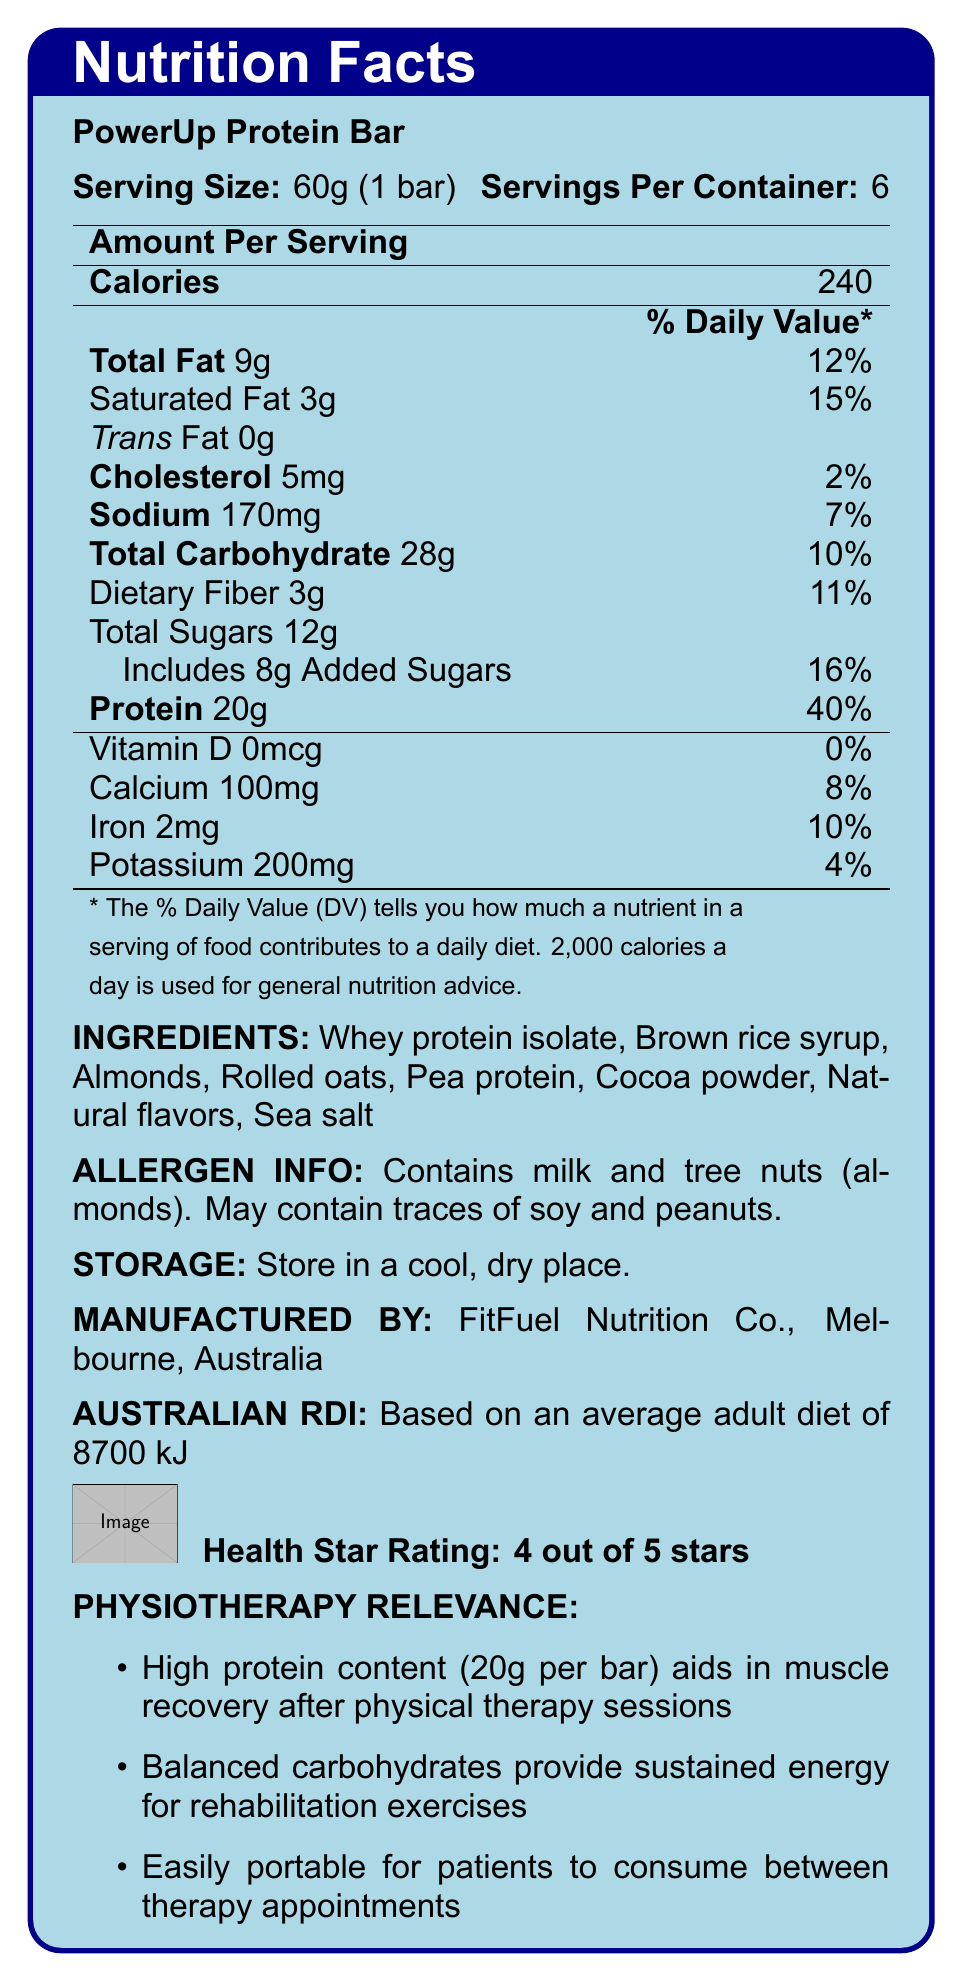what is the serving size of the PowerUp Protein Bar? The document states that the serving size is 60g, which is equivalent to 1 bar.
Answer: 60g (1 bar) how many servings are there per container? The document indicates that there are 6 servings per container.
Answer: 6 how much protein is in one serving of the PowerUp Protein Bar? The document mentions that each serving of the bar contains 20g of protein.
Answer: 20g what allergens are present in the PowerUp Protein Bar? The allergen information section states that the bar contains milk and tree nuts (almonds) and may contain traces of soy and peanuts.
Answer: Milk and tree nuts (almonds), may contain traces of soy and peanuts which company manufactures the PowerUp Protein Bar? The document specifies that the manufacturer is FitFuel Nutrition Co., located in Melbourne, Australia.
Answer: FitFuel Nutrition Co., Melbourne, Australia how many calories are in one serving of the PowerUp Protein Bar? The document states that one serving of the bar contains 240 calories.
Answer: 240 what percentage of the daily value for saturated fat does one serving provide? The document indicates that one serving provides 15% of the daily value for saturated fat.
Answer: 15% which ingredient is listed first on the PowerUp Protein Bar's ingredients list? A. Whey protein isolate B. Brown rice syrup C. Almonds D. Cocoa powder The first ingredient listed on the PowerUp Protein Bar's ingredients list is whey protein isolate.
Answer: A. Whey protein isolate how much sodium is in one serving? A. 170mg B. 200mg C. 170mg D. 2mg The document lists that one serving contains 170mg of sodium.
Answer: A does the PowerUp Protein Bar contain trans fat? Yes/No The document indicates that the bar contains 0g of trans fat.
Answer: No summarize the main ideas presented in the document. The document highlights the nutritional information of the PowerUp Protein Bar, including serving size, protein content, ingredients, allergen warnings, and its relevance to physiotherapy.
Answer: The PowerUp Protein Bar is a high-protein energy bar manufactured by FitFuel Nutrition Co. in Melbourne, Australia. It contains 20g of protein per serving, aiding in muscle recovery, and provides sustained energy for rehabilitation exercises. Each serving is 60g and contains 240 calories, 9g of fat, and 28g of carbohydrates. It includes various ingredients like whey protein isolate, brown rice syrup, and almonds, and has allergen warnings for milk and tree nuts. The bar is portable and convenient for patients to consume between therapy appointments, making it suitable for physiotherapy purposes. what is the health star rating of the PowerUp Protein Bar? The document indicates that the health star rating of the PowerUp Protein Bar is 4 out of 5 stars.
Answer: 4 out of 5 stars how much added sugar is in one serving of the bar? The document specifies that one serving includes 8g of added sugars.
Answer: 8g what daily diet percentage is the Australian Recommended Dietary Intake (RDI) based on? The document states that the Australian RDI is based on an average adult diet of 8700 kJ.
Answer: Average adult diet of 8700 kJ does the PowerUp Protein Bar provide any Vitamin D? The document indicates that the bar contains 0mcg of Vitamin D, which is 0% of the daily value.
Answer: No what are the storage instructions for the PowerUp Protein Bar? According to the document, the storage instructions are to store the bar in a cool, dry place.
Answer: Store in a cool, dry place what are the main ingredients in the PowerUp Protein Bar? The main ingredients listed in the document are whey protein isolate, brown rice syrup, almonds, rolled oats, pea protein, cocoa powder, natural flavors, and sea salt.
Answer: Whey protein isolate, Brown rice syrup, Almonds, Rolled oats, Pea protein, Cocoa powder, Natural flavors, Sea salt what is the serving size in grams per container? The document provides the serving size per bar and the number of servings per container, but not the total grams per container directly.
Answer: Cannot be determined 